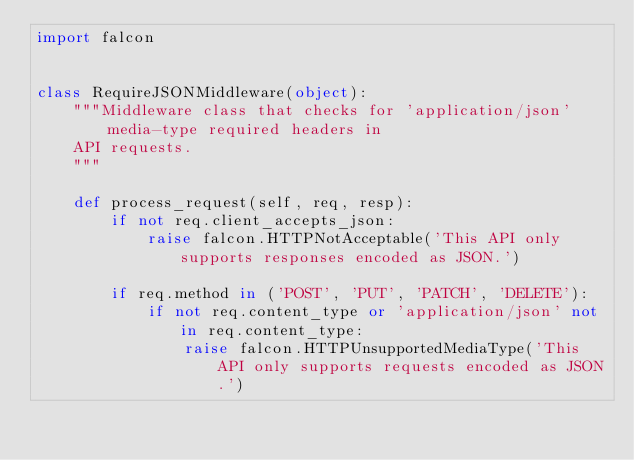<code> <loc_0><loc_0><loc_500><loc_500><_Python_>import falcon


class RequireJSONMiddleware(object):
    """Middleware class that checks for 'application/json' media-type required headers in
    API requests.
    """

    def process_request(self, req, resp):
        if not req.client_accepts_json:
            raise falcon.HTTPNotAcceptable('This API only supports responses encoded as JSON.')

        if req.method in ('POST', 'PUT', 'PATCH', 'DELETE'):
            if not req.content_type or 'application/json' not in req.content_type:
                raise falcon.HTTPUnsupportedMediaType('This API only supports requests encoded as JSON.')
</code> 